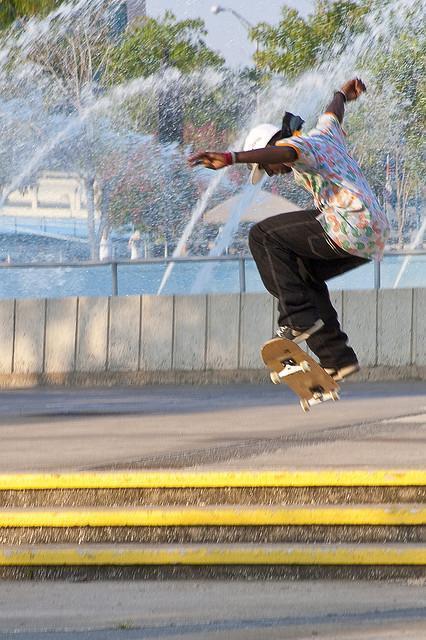How many steps are there?
Give a very brief answer. 3. How many oranges are in the bottom layer?
Give a very brief answer. 0. 